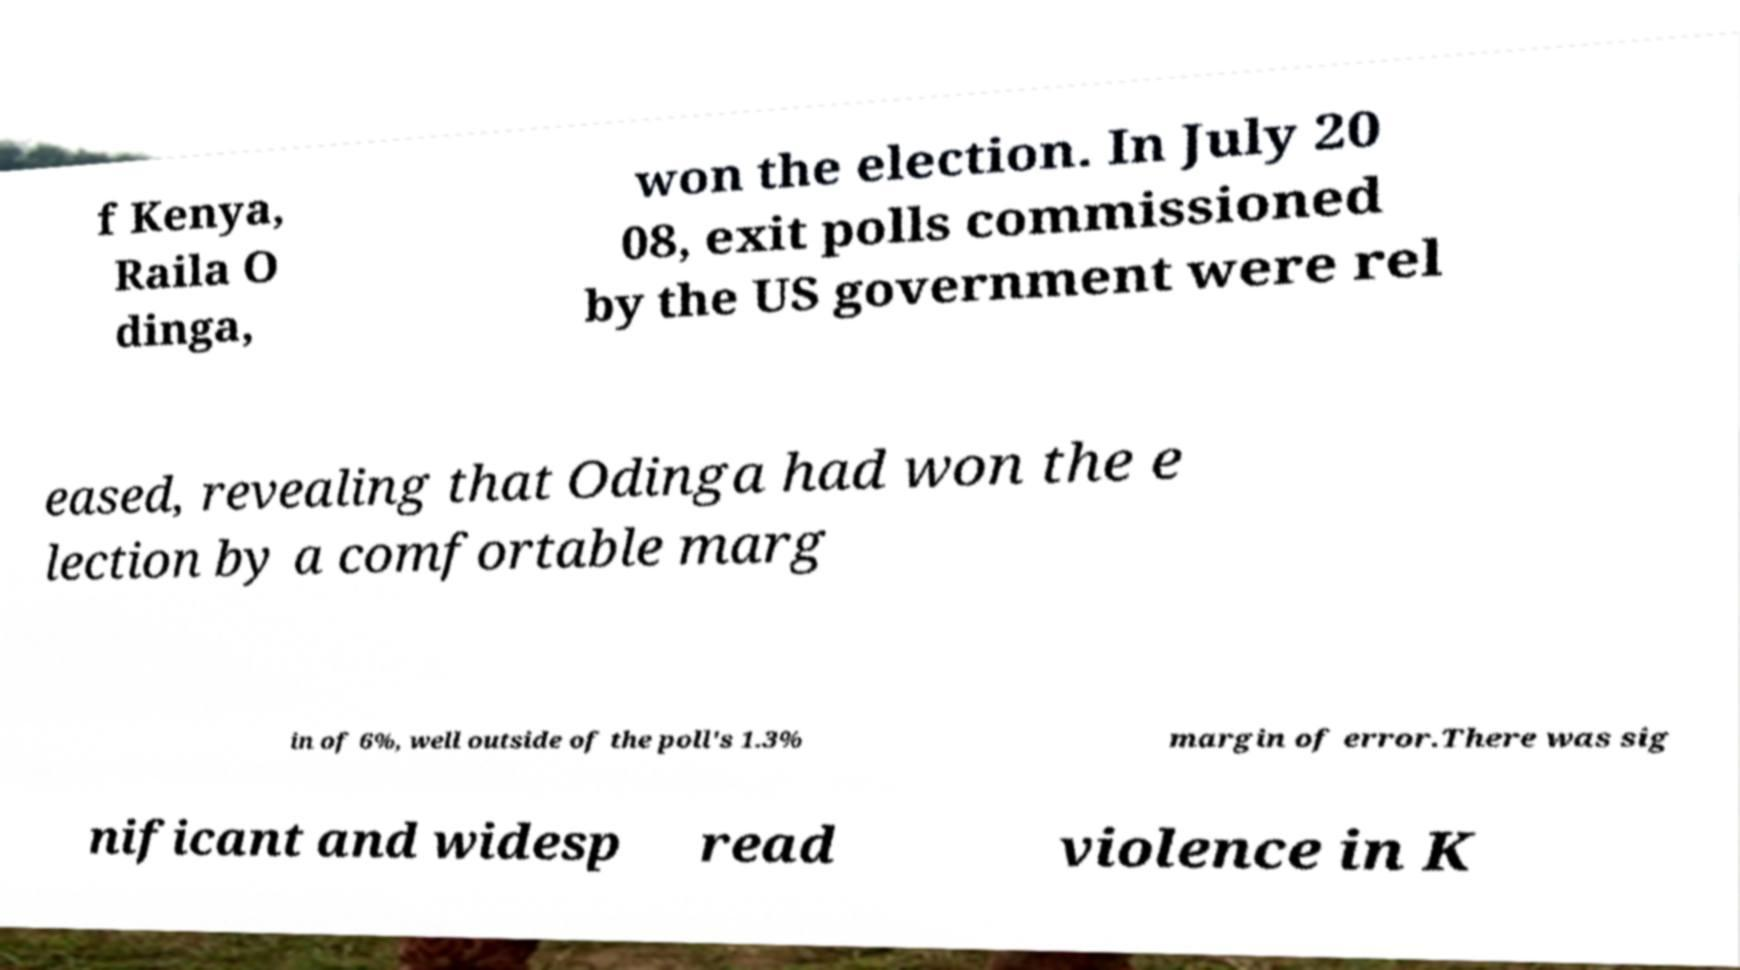What messages or text are displayed in this image? I need them in a readable, typed format. f Kenya, Raila O dinga, won the election. In July 20 08, exit polls commissioned by the US government were rel eased, revealing that Odinga had won the e lection by a comfortable marg in of 6%, well outside of the poll's 1.3% margin of error.There was sig nificant and widesp read violence in K 